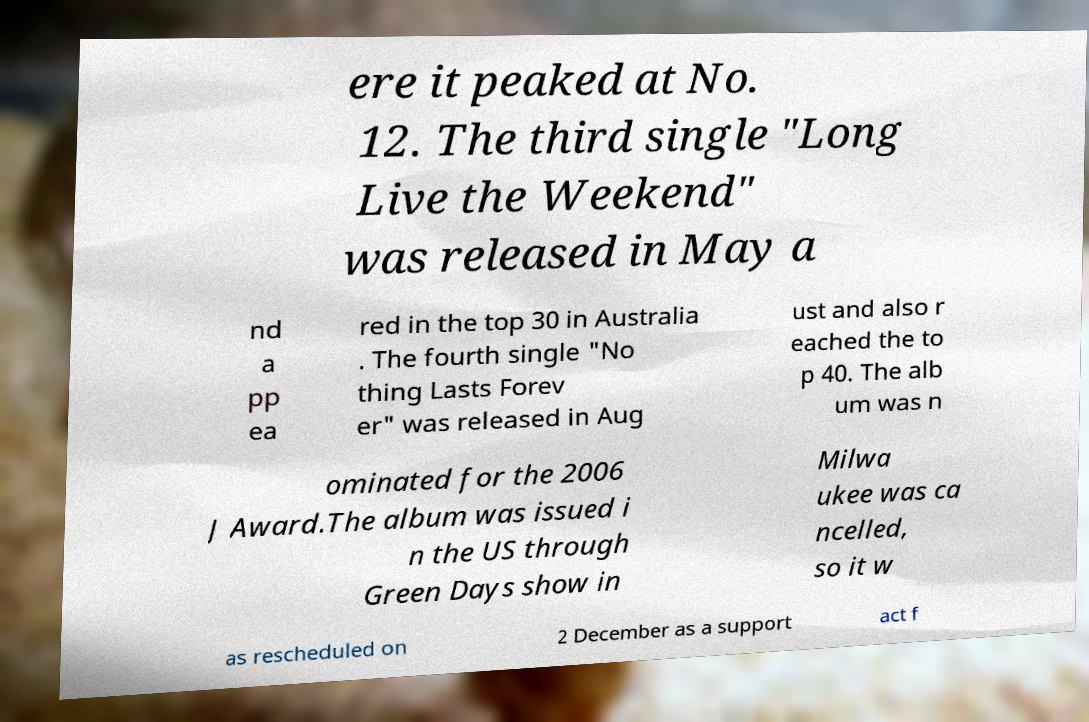Can you accurately transcribe the text from the provided image for me? ere it peaked at No. 12. The third single "Long Live the Weekend" was released in May a nd a pp ea red in the top 30 in Australia . The fourth single "No thing Lasts Forev er" was released in Aug ust and also r eached the to p 40. The alb um was n ominated for the 2006 J Award.The album was issued i n the US through Green Days show in Milwa ukee was ca ncelled, so it w as rescheduled on 2 December as a support act f 